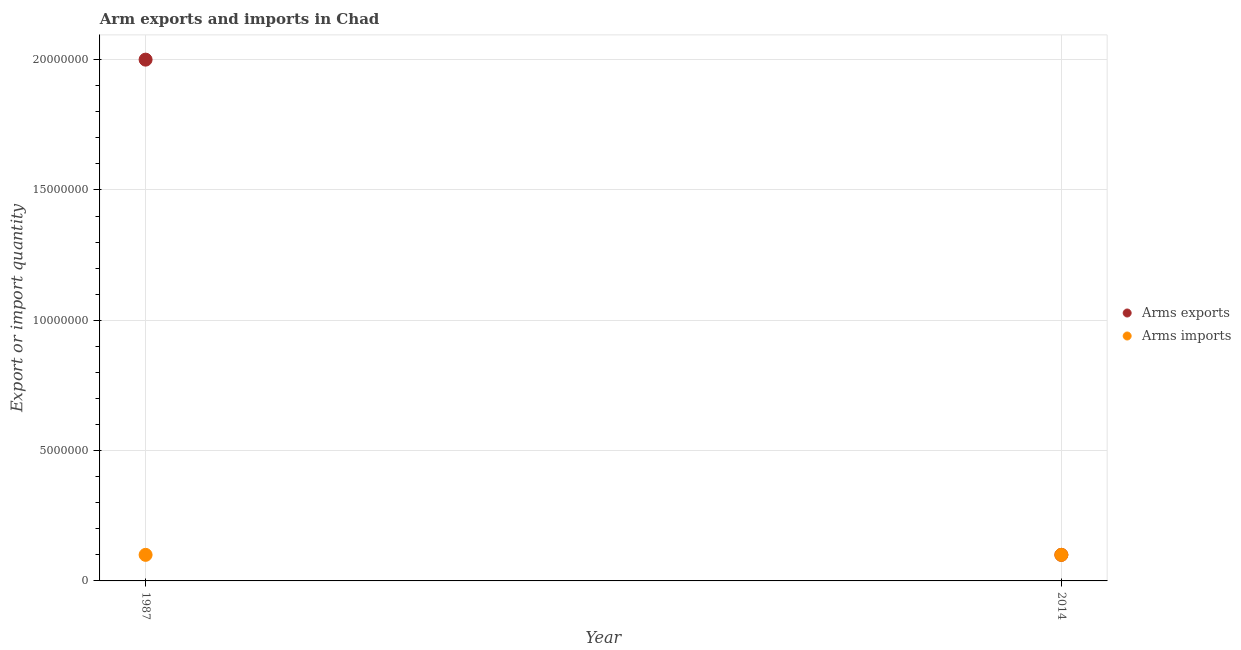Is the number of dotlines equal to the number of legend labels?
Make the answer very short. Yes. What is the arms exports in 1987?
Your answer should be compact. 2.00e+07. Across all years, what is the maximum arms exports?
Give a very brief answer. 2.00e+07. Across all years, what is the minimum arms exports?
Provide a succinct answer. 1.00e+06. What is the total arms exports in the graph?
Keep it short and to the point. 2.10e+07. In the year 1987, what is the difference between the arms imports and arms exports?
Your answer should be very brief. -1.90e+07. In how many years, is the arms imports greater than 2000000?
Ensure brevity in your answer.  0. In how many years, is the arms exports greater than the average arms exports taken over all years?
Make the answer very short. 1. Does the arms exports monotonically increase over the years?
Offer a very short reply. No. How many dotlines are there?
Provide a short and direct response. 2. Does the graph contain any zero values?
Your answer should be very brief. No. How many legend labels are there?
Offer a very short reply. 2. How are the legend labels stacked?
Your answer should be compact. Vertical. What is the title of the graph?
Your answer should be very brief. Arm exports and imports in Chad. What is the label or title of the Y-axis?
Keep it short and to the point. Export or import quantity. What is the Export or import quantity of Arms exports in 1987?
Provide a short and direct response. 2.00e+07. What is the Export or import quantity of Arms imports in 1987?
Make the answer very short. 1.00e+06. What is the Export or import quantity in Arms exports in 2014?
Your answer should be compact. 1.00e+06. What is the total Export or import quantity of Arms exports in the graph?
Provide a succinct answer. 2.10e+07. What is the difference between the Export or import quantity of Arms exports in 1987 and that in 2014?
Give a very brief answer. 1.90e+07. What is the difference between the Export or import quantity of Arms exports in 1987 and the Export or import quantity of Arms imports in 2014?
Offer a terse response. 1.90e+07. What is the average Export or import quantity in Arms exports per year?
Your response must be concise. 1.05e+07. What is the average Export or import quantity of Arms imports per year?
Your answer should be very brief. 1.00e+06. In the year 1987, what is the difference between the Export or import quantity in Arms exports and Export or import quantity in Arms imports?
Your answer should be compact. 1.90e+07. In the year 2014, what is the difference between the Export or import quantity in Arms exports and Export or import quantity in Arms imports?
Provide a succinct answer. 0. What is the ratio of the Export or import quantity of Arms exports in 1987 to that in 2014?
Provide a succinct answer. 20. What is the difference between the highest and the second highest Export or import quantity of Arms exports?
Provide a succinct answer. 1.90e+07. What is the difference between the highest and the lowest Export or import quantity in Arms exports?
Your response must be concise. 1.90e+07. 